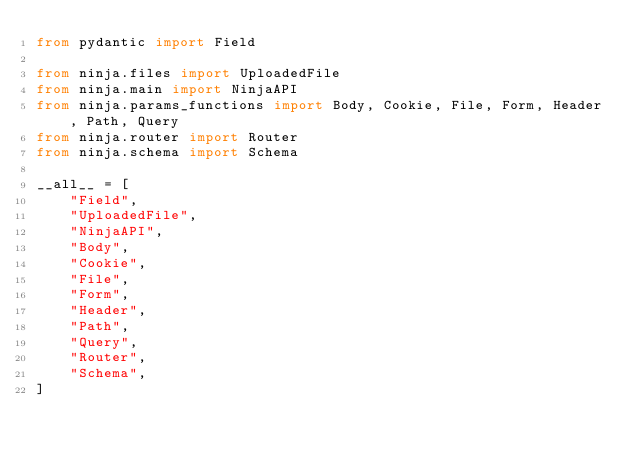Convert code to text. <code><loc_0><loc_0><loc_500><loc_500><_Python_>from pydantic import Field

from ninja.files import UploadedFile
from ninja.main import NinjaAPI
from ninja.params_functions import Body, Cookie, File, Form, Header, Path, Query
from ninja.router import Router
from ninja.schema import Schema

__all__ = [
    "Field",
    "UploadedFile",
    "NinjaAPI",
    "Body",
    "Cookie",
    "File",
    "Form",
    "Header",
    "Path",
    "Query",
    "Router",
    "Schema",
]
</code> 